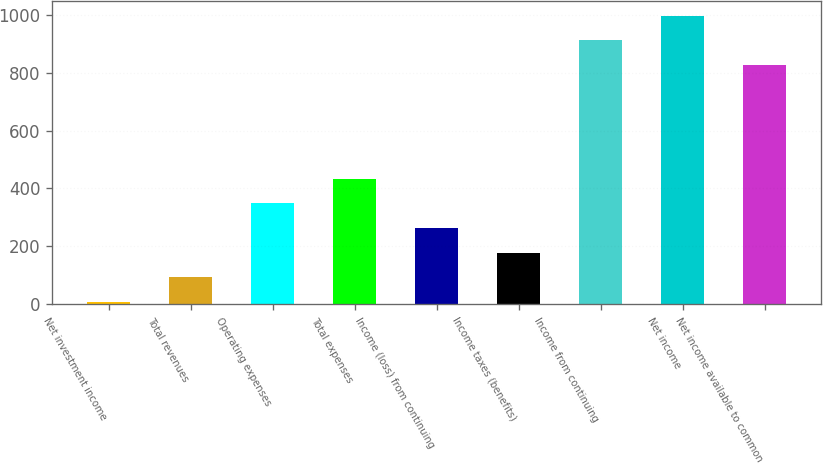<chart> <loc_0><loc_0><loc_500><loc_500><bar_chart><fcel>Net investment income<fcel>Total revenues<fcel>Operating expenses<fcel>Total expenses<fcel>Income (loss) from continuing<fcel>Income taxes (benefits)<fcel>Income from continuing<fcel>Net income<fcel>Net income available to common<nl><fcel>6.8<fcel>92.15<fcel>348.2<fcel>433.55<fcel>262.85<fcel>177.5<fcel>912.65<fcel>998<fcel>827.3<nl></chart> 